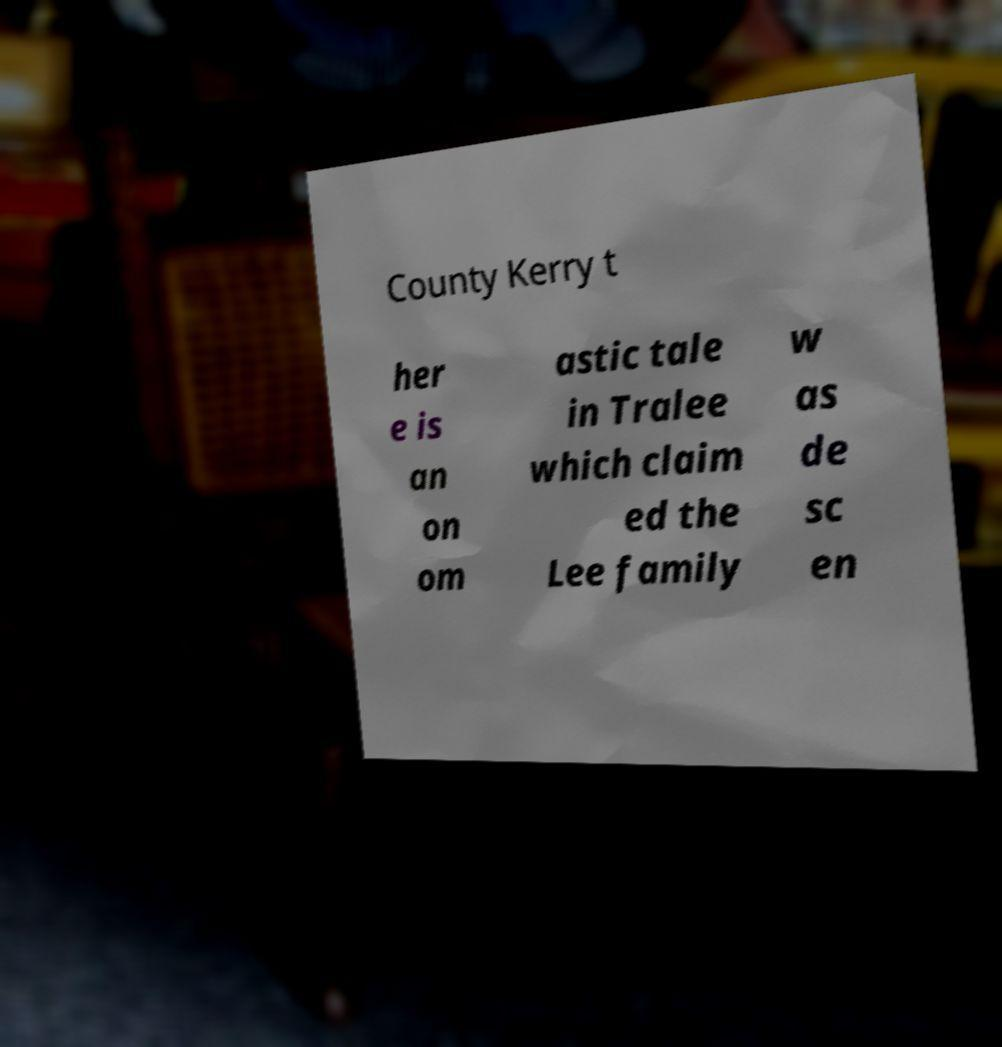Please identify and transcribe the text found in this image. County Kerry t her e is an on om astic tale in Tralee which claim ed the Lee family w as de sc en 